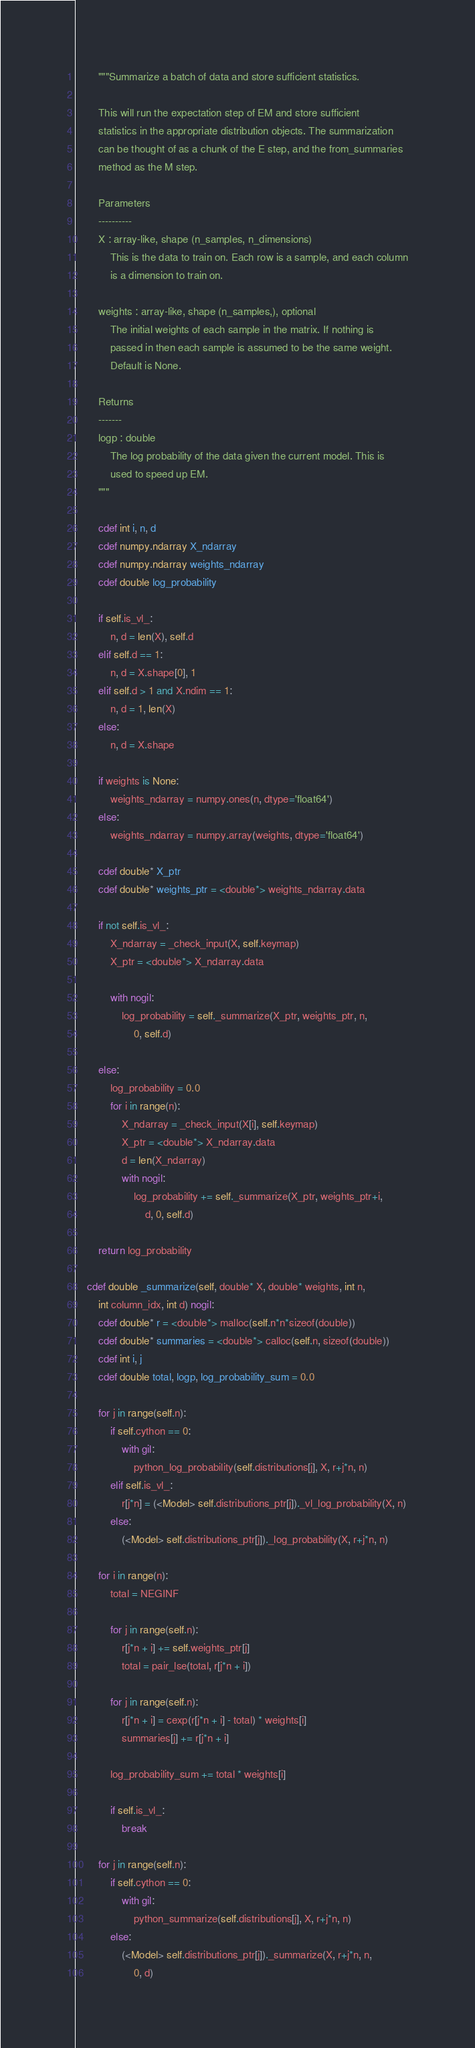<code> <loc_0><loc_0><loc_500><loc_500><_Cython_>        """Summarize a batch of data and store sufficient statistics.

        This will run the expectation step of EM and store sufficient
        statistics in the appropriate distribution objects. The summarization
        can be thought of as a chunk of the E step, and the from_summaries
        method as the M step.

        Parameters
        ----------
        X : array-like, shape (n_samples, n_dimensions)
            This is the data to train on. Each row is a sample, and each column
            is a dimension to train on.

        weights : array-like, shape (n_samples,), optional
            The initial weights of each sample in the matrix. If nothing is
            passed in then each sample is assumed to be the same weight.
            Default is None.

        Returns
        -------
        logp : double
            The log probability of the data given the current model. This is
            used to speed up EM.
        """

        cdef int i, n, d
        cdef numpy.ndarray X_ndarray
        cdef numpy.ndarray weights_ndarray
        cdef double log_probability

        if self.is_vl_:
            n, d = len(X), self.d
        elif self.d == 1:
            n, d = X.shape[0], 1
        elif self.d > 1 and X.ndim == 1:
            n, d = 1, len(X)
        else:
            n, d = X.shape

        if weights is None:
            weights_ndarray = numpy.ones(n, dtype='float64')
        else:
            weights_ndarray = numpy.array(weights, dtype='float64')

        cdef double* X_ptr
        cdef double* weights_ptr = <double*> weights_ndarray.data

        if not self.is_vl_:
            X_ndarray = _check_input(X, self.keymap)
            X_ptr = <double*> X_ndarray.data

            with nogil:
                log_probability = self._summarize(X_ptr, weights_ptr, n,
                    0, self.d)

        else:
            log_probability = 0.0
            for i in range(n):
                X_ndarray = _check_input(X[i], self.keymap)
                X_ptr = <double*> X_ndarray.data
                d = len(X_ndarray)
                with nogil:
                    log_probability += self._summarize(X_ptr, weights_ptr+i,
                        d, 0, self.d)

        return log_probability

    cdef double _summarize(self, double* X, double* weights, int n,
        int column_idx, int d) nogil:
        cdef double* r = <double*> malloc(self.n*n*sizeof(double))
        cdef double* summaries = <double*> calloc(self.n, sizeof(double))
        cdef int i, j
        cdef double total, logp, log_probability_sum = 0.0

        for j in range(self.n):
            if self.cython == 0:
                with gil:
                    python_log_probability(self.distributions[j], X, r+j*n, n)
            elif self.is_vl_:
                r[j*n] = (<Model> self.distributions_ptr[j])._vl_log_probability(X, n)
            else:
                (<Model> self.distributions_ptr[j])._log_probability(X, r+j*n, n)

        for i in range(n):
            total = NEGINF

            for j in range(self.n):
                r[j*n + i] += self.weights_ptr[j]
                total = pair_lse(total, r[j*n + i])

            for j in range(self.n):
                r[j*n + i] = cexp(r[j*n + i] - total) * weights[i]
                summaries[j] += r[j*n + i]

            log_probability_sum += total * weights[i]

            if self.is_vl_:
                break

        for j in range(self.n):
            if self.cython == 0:
                with gil:
                    python_summarize(self.distributions[j], X, r+j*n, n)
            else:
                (<Model> self.distributions_ptr[j])._summarize(X, r+j*n, n,
                    0, d)
</code> 